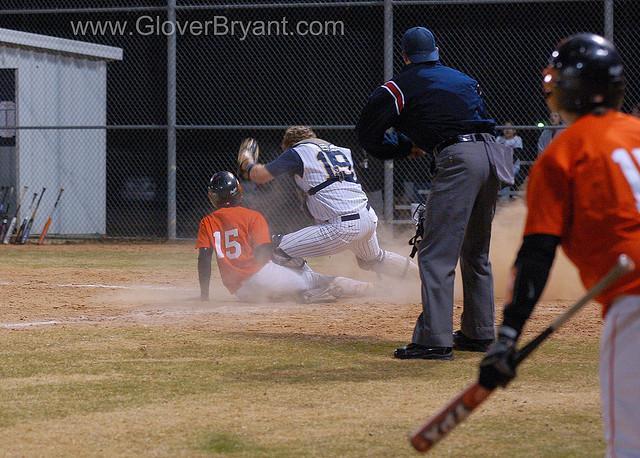What action caused the dust to fly?
Select the correct answer and articulate reasoning with the following format: 'Answer: answer
Rationale: rationale.'
Options: Bats, waving arms, sliding, running. Answer: sliding.
Rationale: A baseball player is on the ground with another from the opposing team  there as well. 